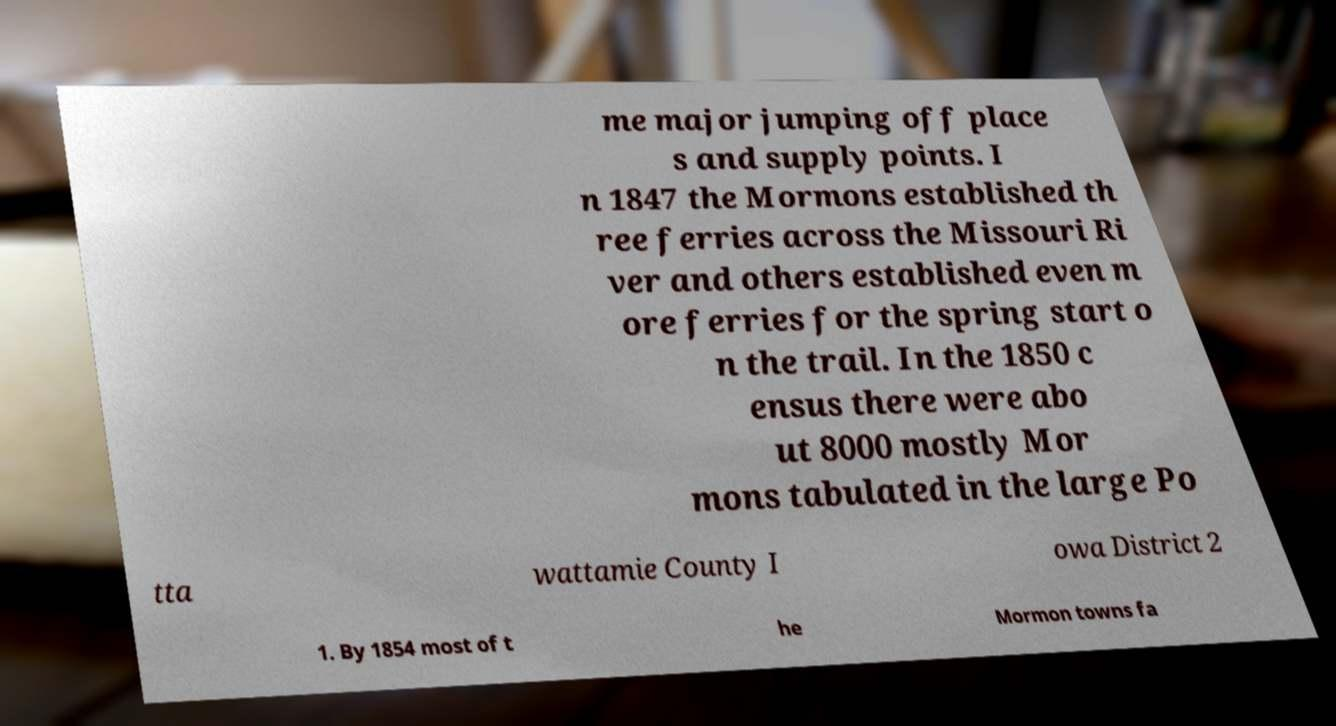For documentation purposes, I need the text within this image transcribed. Could you provide that? me major jumping off place s and supply points. I n 1847 the Mormons established th ree ferries across the Missouri Ri ver and others established even m ore ferries for the spring start o n the trail. In the 1850 c ensus there were abo ut 8000 mostly Mor mons tabulated in the large Po tta wattamie County I owa District 2 1. By 1854 most of t he Mormon towns fa 